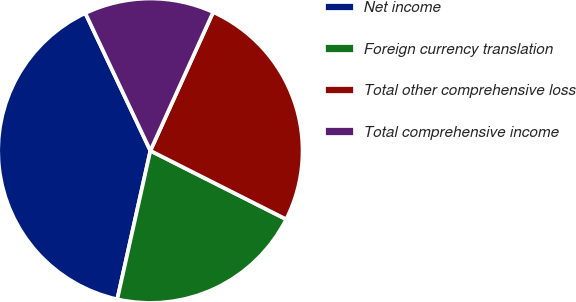<chart> <loc_0><loc_0><loc_500><loc_500><pie_chart><fcel>Net income<fcel>Foreign currency translation<fcel>Total other comprehensive loss<fcel>Total comprehensive income<nl><fcel>39.48%<fcel>21.05%<fcel>25.67%<fcel>13.8%<nl></chart> 